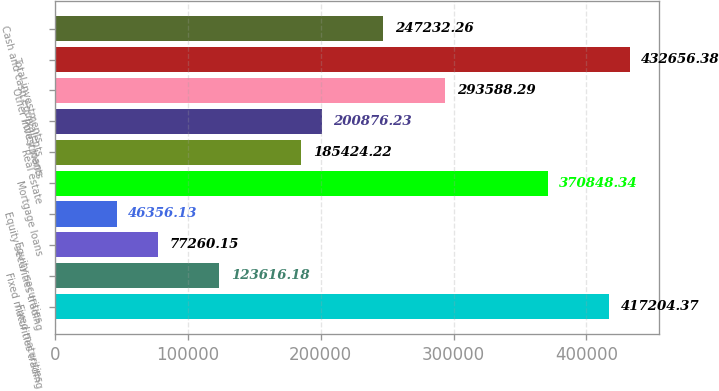<chart> <loc_0><loc_0><loc_500><loc_500><bar_chart><fcel>Fixed maturities<fcel>Fixed maturities trading<fcel>Equity securities<fcel>Equity securities trading<fcel>Mortgage loans<fcel>Real estate<fcel>Policy loans<fcel>Other investments<fcel>Total investments<fcel>Cash and cash equivalents<nl><fcel>417204<fcel>123616<fcel>77260.1<fcel>46356.1<fcel>370848<fcel>185424<fcel>200876<fcel>293588<fcel>432656<fcel>247232<nl></chart> 